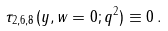Convert formula to latex. <formula><loc_0><loc_0><loc_500><loc_500>\tau _ { 2 , 6 , 8 } ( y , w = 0 ; q ^ { 2 } ) \equiv 0 \, .</formula> 